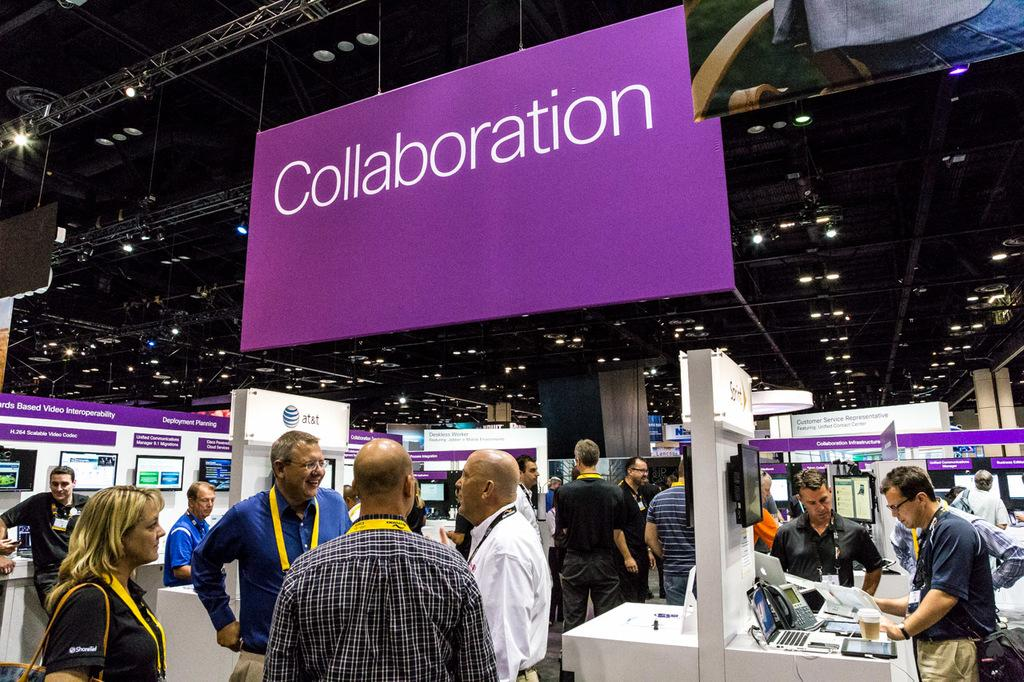<image>
Create a compact narrative representing the image presented. a convention hall with a large purple sign reading collaboration over head. 